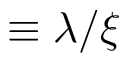Convert formula to latex. <formula><loc_0><loc_0><loc_500><loc_500>\equiv \lambda / \xi</formula> 